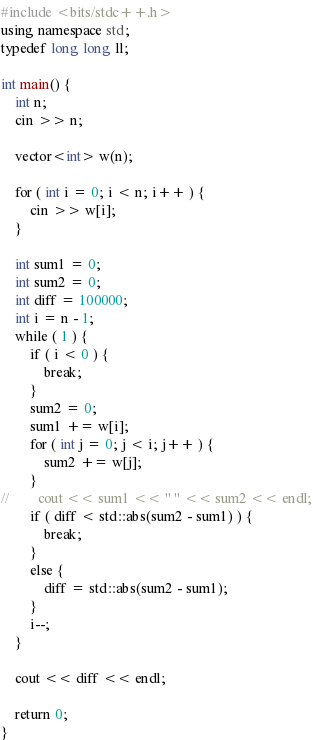<code> <loc_0><loc_0><loc_500><loc_500><_C++_>#include <bits/stdc++.h>
using namespace std;
typedef long long ll;

int main() {
    int n;
    cin >> n;

    vector<int> w(n);

    for ( int i = 0; i < n; i++ ) {
        cin >> w[i];
    }

    int sum1 = 0;
    int sum2 = 0;
    int diff = 100000;
    int i = n - 1;
    while ( 1 ) {
        if ( i < 0 ) {
            break;
        }
        sum2 = 0;
        sum1 += w[i];
        for ( int j = 0; j < i; j++ ) {
            sum2 += w[j];
        }
//        cout << sum1 << " " << sum2 << endl;
        if ( diff < std::abs(sum2 - sum1) ) {
            break;
        }
        else {
            diff = std::abs(sum2 - sum1);
        }
        i--;
    }

    cout << diff << endl;

    return 0;
}</code> 